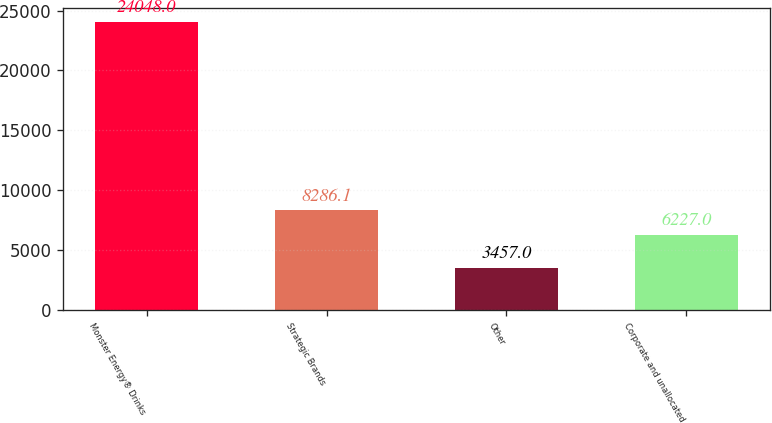Convert chart. <chart><loc_0><loc_0><loc_500><loc_500><bar_chart><fcel>Monster Energy® Drinks<fcel>Strategic Brands<fcel>Other<fcel>Corporate and unallocated<nl><fcel>24048<fcel>8286.1<fcel>3457<fcel>6227<nl></chart> 